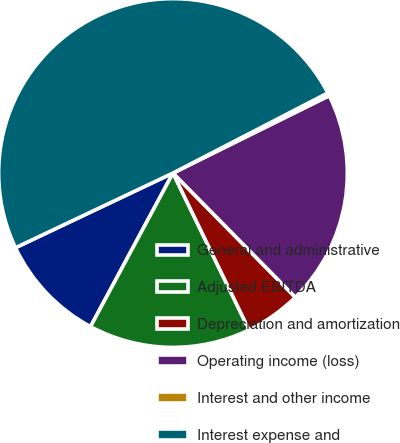Convert chart to OTSL. <chart><loc_0><loc_0><loc_500><loc_500><pie_chart><fcel>General and administrative<fcel>Adjusted EBITDA<fcel>Depreciation and amortization<fcel>Operating income (loss)<fcel>Interest and other income<fcel>Interest expense and<nl><fcel>10.11%<fcel>15.03%<fcel>5.19%<fcel>19.94%<fcel>0.28%<fcel>49.45%<nl></chart> 